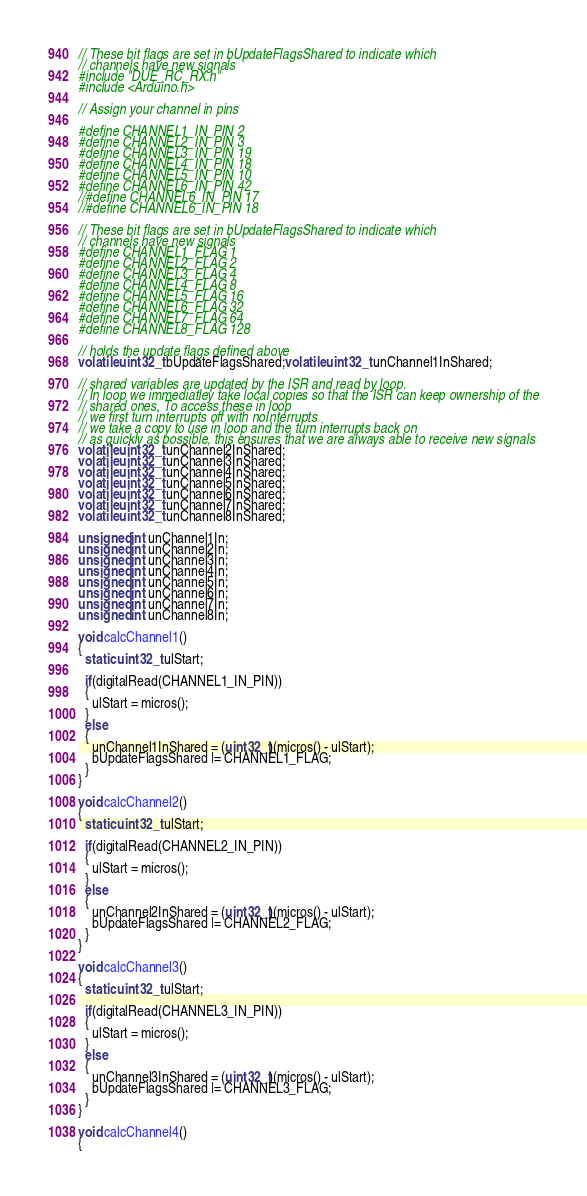Convert code to text. <code><loc_0><loc_0><loc_500><loc_500><_C++_>// These bit flags are set in bUpdateFlagsShared to indicate which
// channels have new signals
#include "DUE_RC_RX.h"
#include <Arduino.h>

// Assign your channel in pins

#define CHANNEL1_IN_PIN 2
#define CHANNEL2_IN_PIN 3
#define CHANNEL3_IN_PIN 19
#define CHANNEL4_IN_PIN 18
#define CHANNEL5_IN_PIN 10
#define CHANNEL6_IN_PIN 42
//#define CHANNEL6_IN_PIN 17
//#define CHANNEL6_IN_PIN 18

// These bit flags are set in bUpdateFlagsShared to indicate which
// channels have new signals
#define CHANNEL1_FLAG 1
#define CHANNEL2_FLAG 2
#define CHANNEL3_FLAG 4
#define CHANNEL4_FLAG 8
#define CHANNEL5_FLAG 16
#define CHANNEL6_FLAG 32
#define CHANNEL7_FLAG 64
#define CHANNEL8_FLAG 128

// holds the update flags defined above
volatile uint32_t bUpdateFlagsShared;volatile uint32_t unChannel1InShared;

// shared variables are updated by the ISR and read by loop.
// In loop we immediatley take local copies so that the ISR can keep ownership of the
// shared ones. To access these in loop
// we first turn interrupts off with noInterrupts
// we take a copy to use in loop and the turn interrupts back on
// as quickly as possible, this ensures that we are always able to receive new signals
volatile uint32_t unChannel2InShared;
volatile uint32_t unChannel3InShared;
volatile uint32_t unChannel4InShared;
volatile uint32_t unChannel5InShared;
volatile uint32_t unChannel6InShared;
volatile uint32_t unChannel7InShared;
volatile uint32_t unChannel8InShared;

unsigned int unChannel1In;
unsigned int unChannel2In;
unsigned int unChannel3In;
unsigned int unChannel4In;
unsigned int unChannel5In;
unsigned int unChannel6In;
unsigned int unChannel7In;
unsigned int unChannel8In;

void calcChannel1()
{
  static uint32_t ulStart;
 
  if(digitalRead(CHANNEL1_IN_PIN))
  {
    ulStart = micros();
  }
  else
  {
    unChannel1InShared = (uint32_t)(micros() - ulStart);
    bUpdateFlagsShared |= CHANNEL1_FLAG;
  }
}

void calcChannel2()
{
  static uint32_t ulStart;
 
  if(digitalRead(CHANNEL2_IN_PIN))
  {
    ulStart = micros();
  }
  else
  {
    unChannel2InShared = (uint32_t)(micros() - ulStart);
    bUpdateFlagsShared |= CHANNEL2_FLAG;
  }
}

void calcChannel3()
{
  static uint32_t ulStart;
 
  if(digitalRead(CHANNEL3_IN_PIN))
  {
    ulStart = micros();
  }
  else
  {
    unChannel3InShared = (uint32_t)(micros() - ulStart);
    bUpdateFlagsShared |= CHANNEL3_FLAG;
  }
}

void calcChannel4()
{</code> 